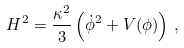<formula> <loc_0><loc_0><loc_500><loc_500>H ^ { 2 } = \frac { \kappa ^ { 2 } } { 3 } \left ( \dot { \phi } ^ { 2 } + V ( \phi ) \right ) \, ,</formula> 